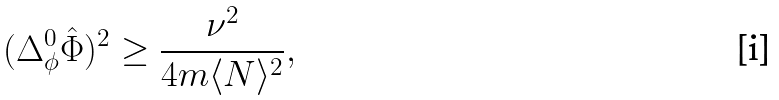Convert formula to latex. <formula><loc_0><loc_0><loc_500><loc_500>( \Delta _ { \phi } ^ { 0 } \hat { \Phi } ) ^ { 2 } \geq \frac { \nu ^ { 2 } } { 4 m \langle N \rangle ^ { 2 } } ,</formula> 